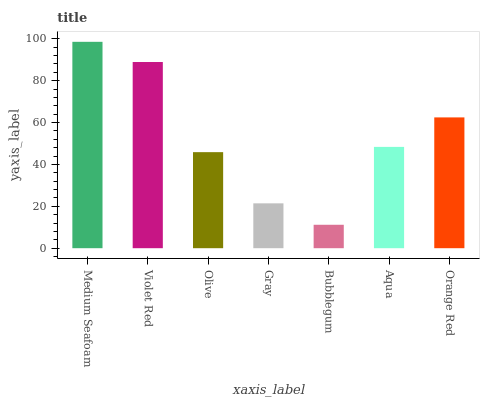Is Bubblegum the minimum?
Answer yes or no. Yes. Is Medium Seafoam the maximum?
Answer yes or no. Yes. Is Violet Red the minimum?
Answer yes or no. No. Is Violet Red the maximum?
Answer yes or no. No. Is Medium Seafoam greater than Violet Red?
Answer yes or no. Yes. Is Violet Red less than Medium Seafoam?
Answer yes or no. Yes. Is Violet Red greater than Medium Seafoam?
Answer yes or no. No. Is Medium Seafoam less than Violet Red?
Answer yes or no. No. Is Aqua the high median?
Answer yes or no. Yes. Is Aqua the low median?
Answer yes or no. Yes. Is Bubblegum the high median?
Answer yes or no. No. Is Bubblegum the low median?
Answer yes or no. No. 